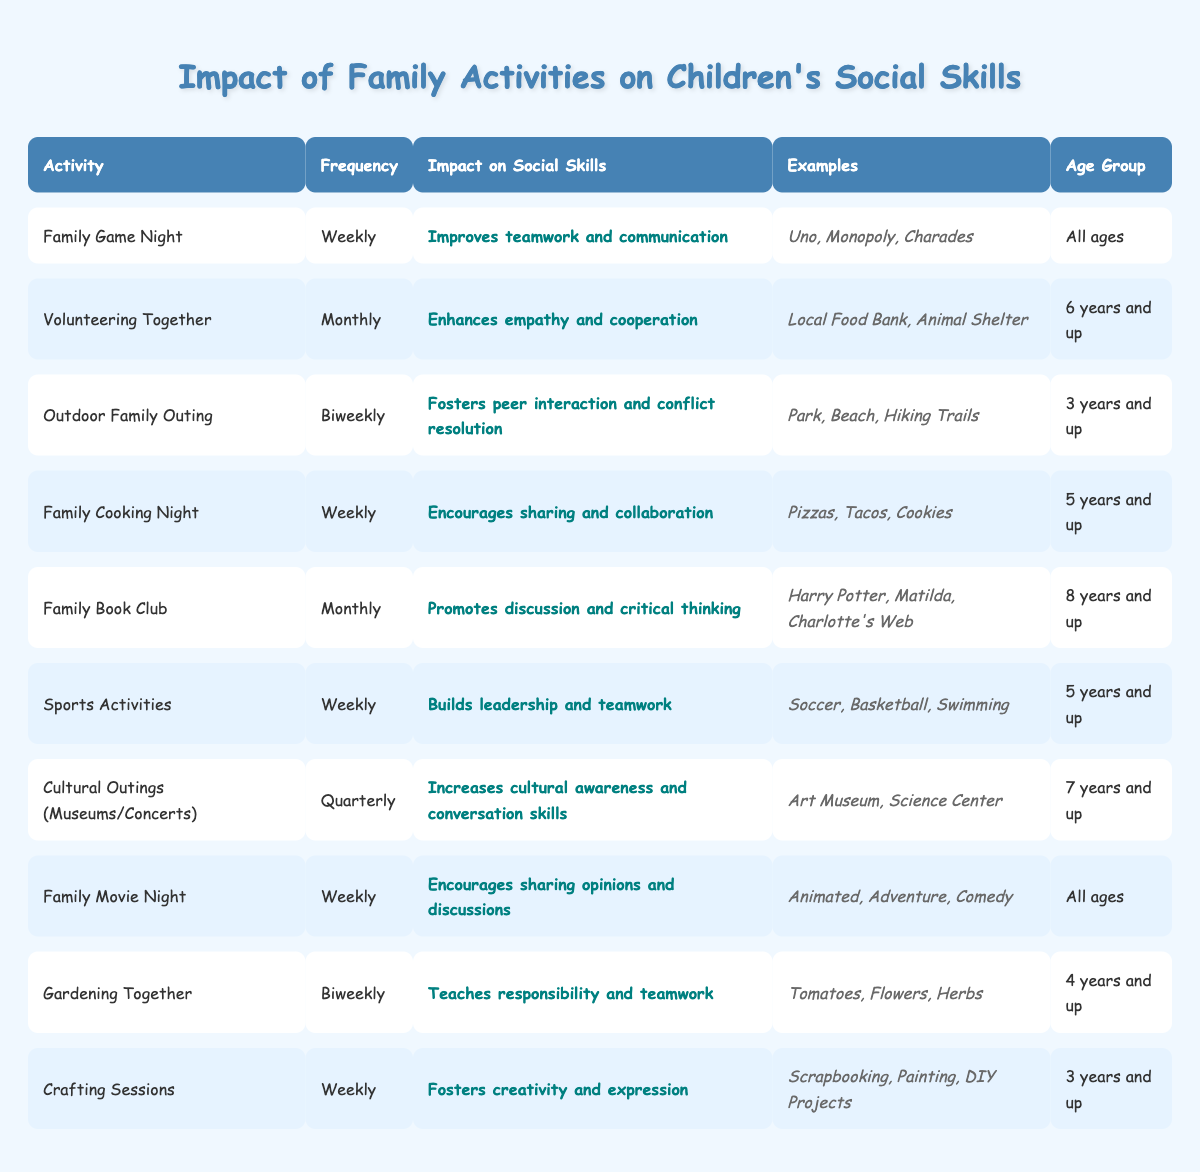What is the impact of Family Game Night on children's social skills? The table states that Family Game Night "Improves teamwork and communication" as its impact on social skills.
Answer: Improves teamwork and communication How often should families engage in Volunteering Together? According to the table, families should participate in Volunteering Together on a "Monthly" basis.
Answer: Monthly Can children under 6 participate in Outdoor Family Outings? The table indicates that Outdoor Family Outings are suitable for "3 years and up," meaning children under 6 can participate.
Answer: Yes What are some examples of activities for Family Cooking Night? The table lists "Pizzas, Tacos, Cookies" as examples of dishes for Family Cooking Night.
Answer: Pizzas, Tacos, Cookies Which activity promotes discussion and critical thinking? Family Book Club is indicated in the table as promoting "discussion and critical thinking."
Answer: Family Book Club How many activities listed occur weekly? The table shows 6 activities occurring weekly: Family Game Night, Family Cooking Night, Sports Activities, Family Movie Night, Crafting Sessions, and Gardening Together.
Answer: 6 Is it true that Family Movie Night is suitable for all ages? Yes, the table confirms that Family Movie Night is suitable for "All ages."
Answer: True Which family activity has the least frequency, and how often does it occur? Cultural Outings (Museums/Concerts) occurs quarterly, making it the least frequent activity in the table.
Answer: Quarterly What is the overall impact of Sports Activities on social skills? The impact listed for Sports Activities is that it "Builds leadership and teamwork."
Answer: Builds leadership and teamwork How many activities are recommended for children aged 5 years and up? The table shows 4 activities recommended for this age group: Family Cooking Night, Sports Activities, Gardening Together, and Crafting Sessions.
Answer: 4 